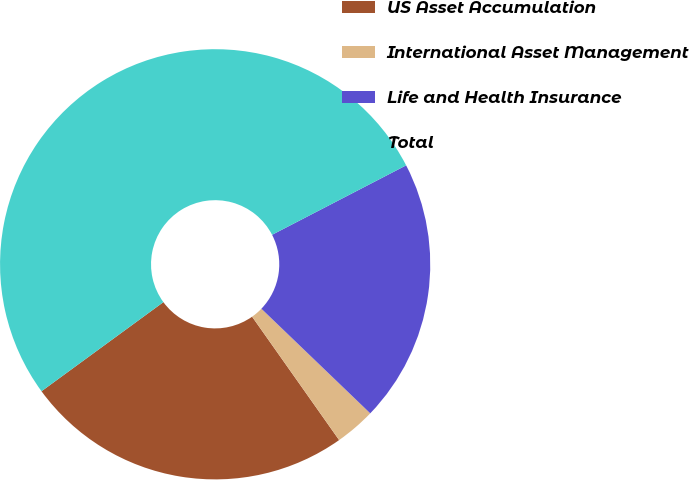Convert chart to OTSL. <chart><loc_0><loc_0><loc_500><loc_500><pie_chart><fcel>US Asset Accumulation<fcel>International Asset Management<fcel>Life and Health Insurance<fcel>Total<nl><fcel>24.73%<fcel>3.04%<fcel>19.79%<fcel>52.44%<nl></chart> 